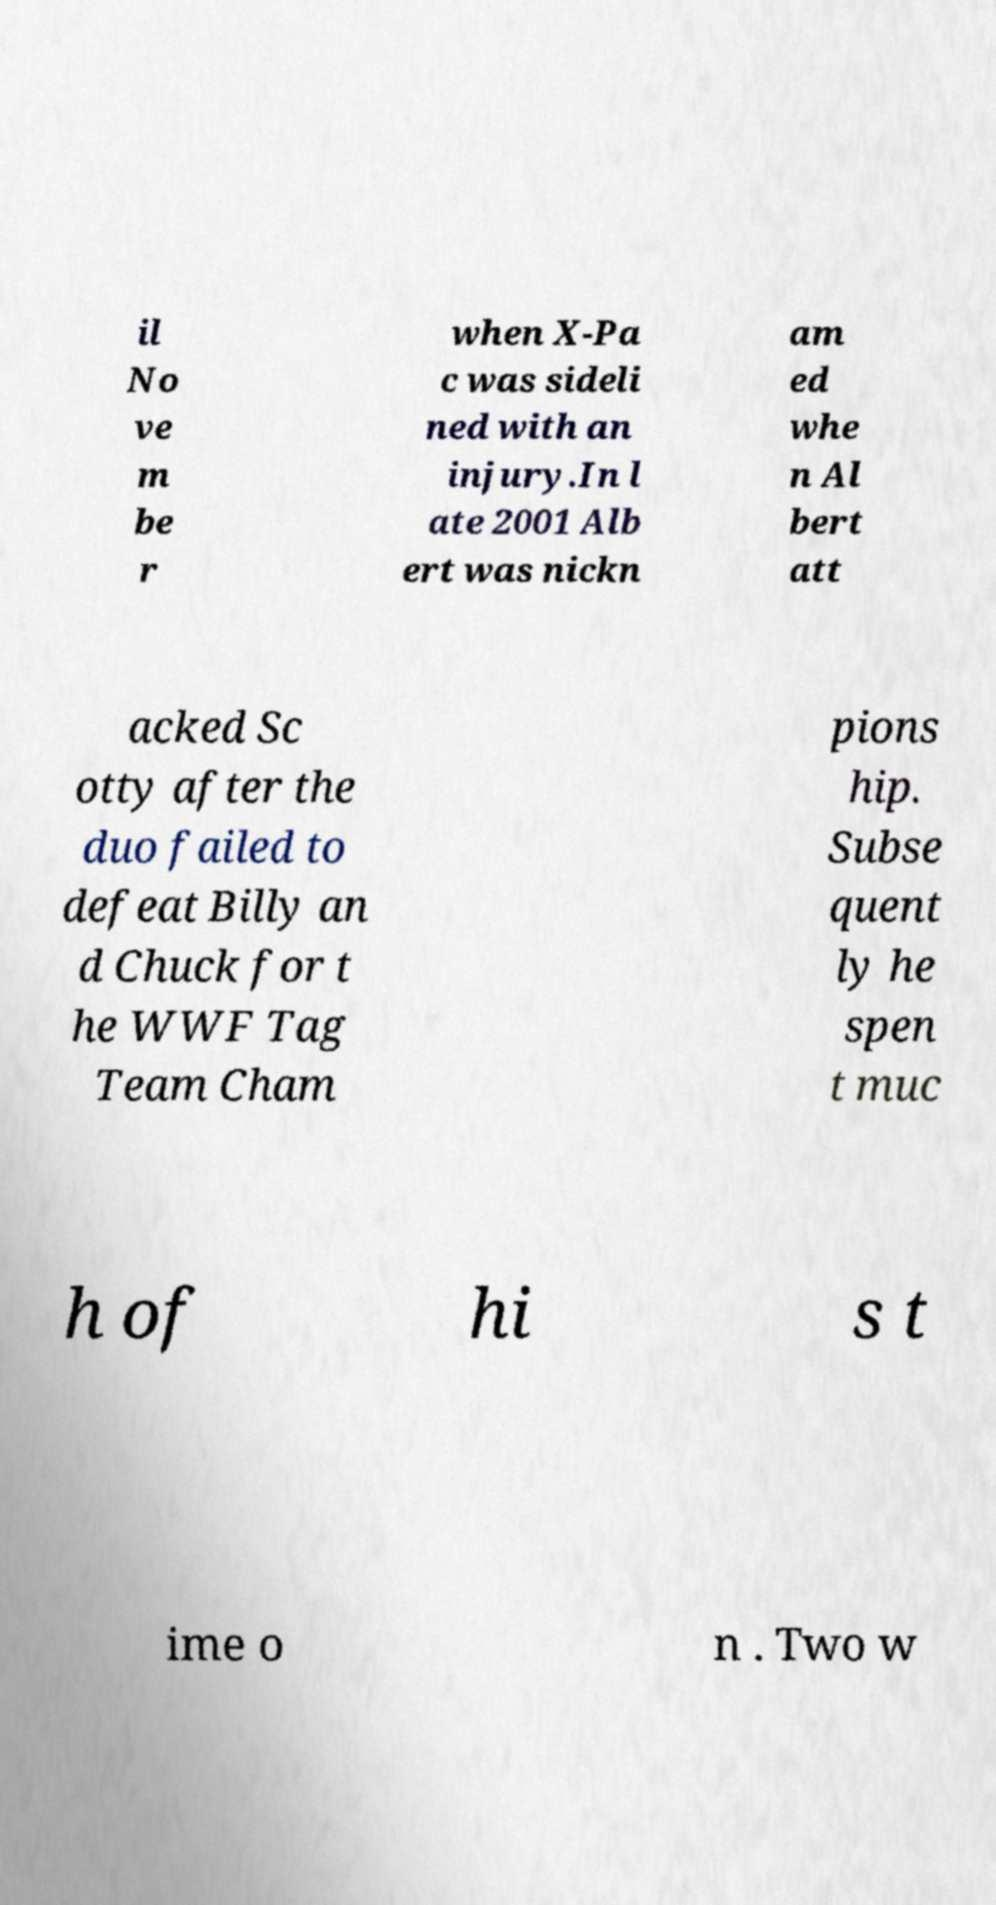For documentation purposes, I need the text within this image transcribed. Could you provide that? il No ve m be r when X-Pa c was sideli ned with an injury.In l ate 2001 Alb ert was nickn am ed whe n Al bert att acked Sc otty after the duo failed to defeat Billy an d Chuck for t he WWF Tag Team Cham pions hip. Subse quent ly he spen t muc h of hi s t ime o n . Two w 